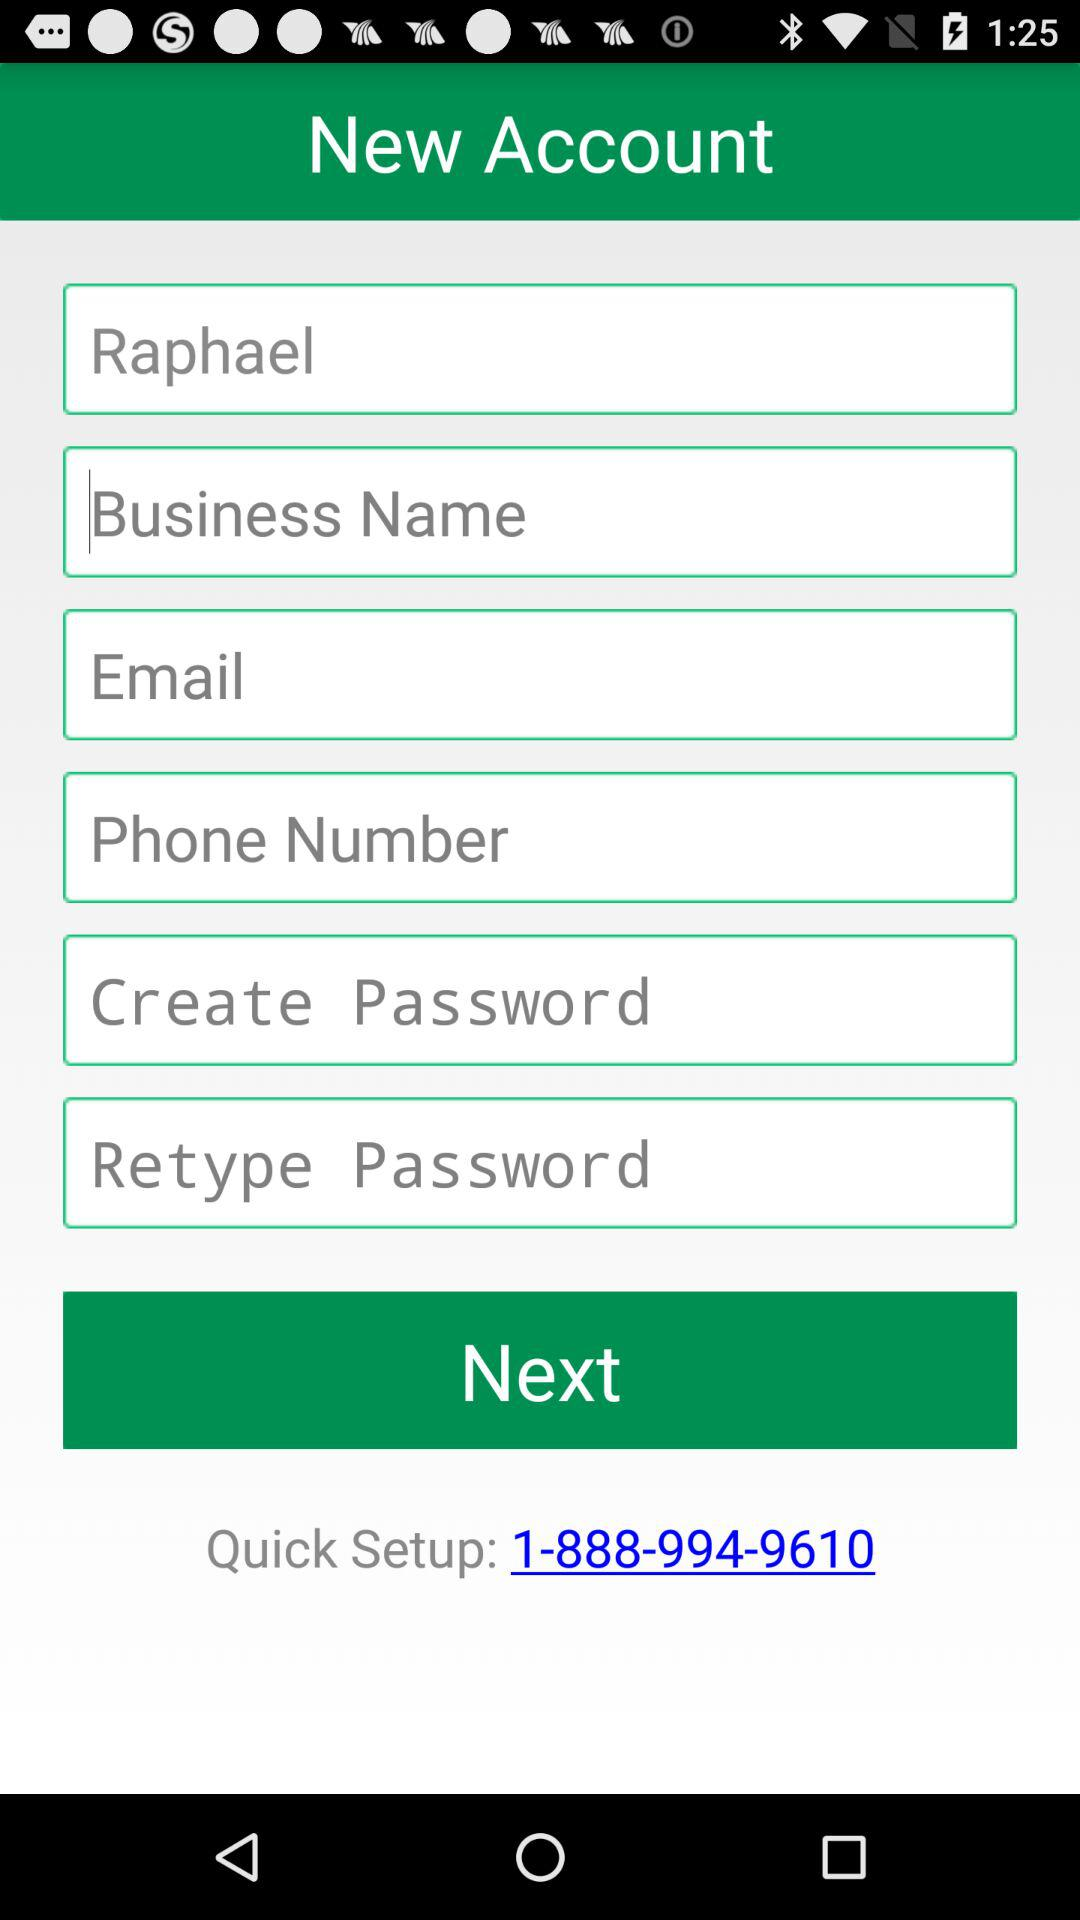What is the first name? The first name is "Raphael". 